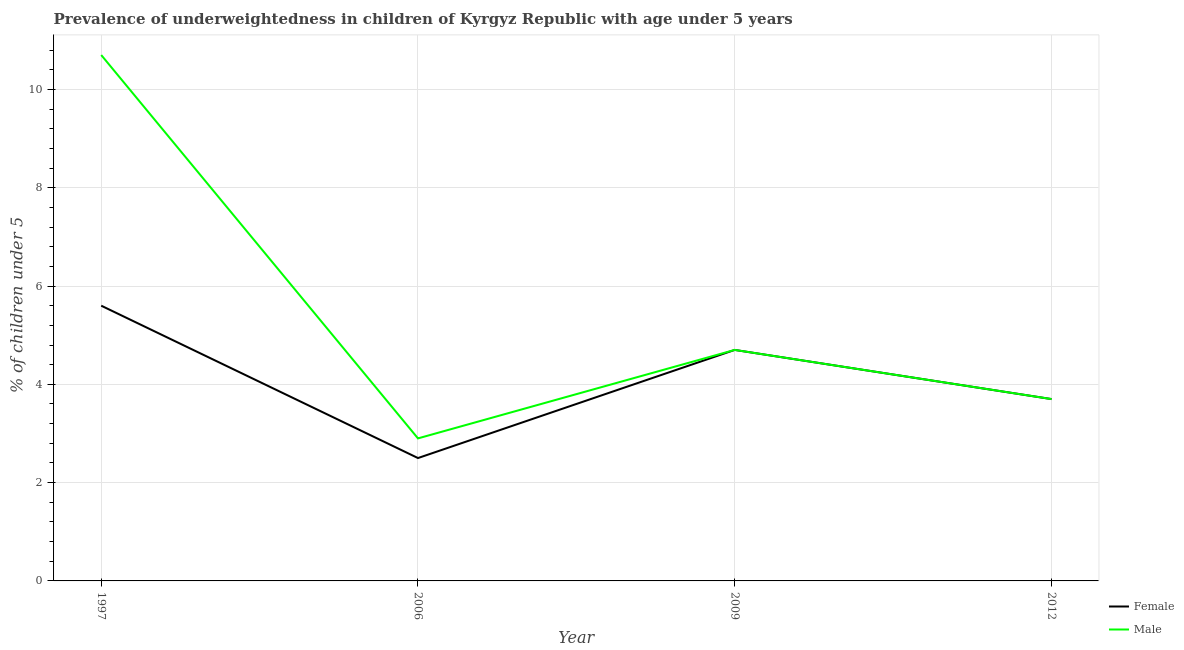How many different coloured lines are there?
Your response must be concise. 2. Across all years, what is the maximum percentage of underweighted female children?
Give a very brief answer. 5.6. In which year was the percentage of underweighted female children maximum?
Give a very brief answer. 1997. What is the total percentage of underweighted female children in the graph?
Provide a short and direct response. 16.5. What is the difference between the percentage of underweighted male children in 1997 and that in 2012?
Give a very brief answer. 7. What is the difference between the percentage of underweighted female children in 2009 and the percentage of underweighted male children in 1997?
Offer a very short reply. -6. What is the average percentage of underweighted female children per year?
Provide a succinct answer. 4.12. What is the ratio of the percentage of underweighted male children in 1997 to that in 2012?
Your response must be concise. 2.89. Is the difference between the percentage of underweighted female children in 2006 and 2012 greater than the difference between the percentage of underweighted male children in 2006 and 2012?
Make the answer very short. No. What is the difference between the highest and the second highest percentage of underweighted female children?
Your answer should be compact. 0.9. What is the difference between the highest and the lowest percentage of underweighted female children?
Keep it short and to the point. 3.1. In how many years, is the percentage of underweighted male children greater than the average percentage of underweighted male children taken over all years?
Your answer should be compact. 1. Is the sum of the percentage of underweighted male children in 1997 and 2009 greater than the maximum percentage of underweighted female children across all years?
Provide a short and direct response. Yes. Does the percentage of underweighted male children monotonically increase over the years?
Provide a short and direct response. No. Is the percentage of underweighted male children strictly greater than the percentage of underweighted female children over the years?
Ensure brevity in your answer.  No. Is the percentage of underweighted female children strictly less than the percentage of underweighted male children over the years?
Make the answer very short. No. How many lines are there?
Provide a succinct answer. 2. How many years are there in the graph?
Your answer should be compact. 4. What is the difference between two consecutive major ticks on the Y-axis?
Provide a succinct answer. 2. Are the values on the major ticks of Y-axis written in scientific E-notation?
Give a very brief answer. No. Does the graph contain any zero values?
Provide a short and direct response. No. How many legend labels are there?
Keep it short and to the point. 2. How are the legend labels stacked?
Your answer should be compact. Vertical. What is the title of the graph?
Keep it short and to the point. Prevalence of underweightedness in children of Kyrgyz Republic with age under 5 years. Does "Net National savings" appear as one of the legend labels in the graph?
Offer a very short reply. No. What is the label or title of the X-axis?
Your response must be concise. Year. What is the label or title of the Y-axis?
Give a very brief answer.  % of children under 5. What is the  % of children under 5 in Female in 1997?
Offer a very short reply. 5.6. What is the  % of children under 5 in Male in 1997?
Offer a terse response. 10.7. What is the  % of children under 5 in Male in 2006?
Offer a terse response. 2.9. What is the  % of children under 5 of Female in 2009?
Offer a very short reply. 4.7. What is the  % of children under 5 in Male in 2009?
Give a very brief answer. 4.7. What is the  % of children under 5 in Female in 2012?
Your answer should be very brief. 3.7. What is the  % of children under 5 of Male in 2012?
Your answer should be compact. 3.7. Across all years, what is the maximum  % of children under 5 of Female?
Give a very brief answer. 5.6. Across all years, what is the maximum  % of children under 5 of Male?
Give a very brief answer. 10.7. Across all years, what is the minimum  % of children under 5 of Male?
Ensure brevity in your answer.  2.9. What is the total  % of children under 5 in Male in the graph?
Keep it short and to the point. 22. What is the difference between the  % of children under 5 of Male in 1997 and that in 2006?
Your answer should be compact. 7.8. What is the difference between the  % of children under 5 in Female in 1997 and that in 2009?
Provide a short and direct response. 0.9. What is the difference between the  % of children under 5 in Female in 1997 and that in 2012?
Ensure brevity in your answer.  1.9. What is the difference between the  % of children under 5 in Female in 2006 and that in 2009?
Give a very brief answer. -2.2. What is the difference between the  % of children under 5 of Male in 2006 and that in 2012?
Offer a very short reply. -0.8. What is the difference between the  % of children under 5 in Female in 1997 and the  % of children under 5 in Male in 2006?
Keep it short and to the point. 2.7. What is the difference between the  % of children under 5 of Female in 1997 and the  % of children under 5 of Male in 2012?
Provide a short and direct response. 1.9. What is the average  % of children under 5 in Female per year?
Your answer should be very brief. 4.12. In the year 2006, what is the difference between the  % of children under 5 of Female and  % of children under 5 of Male?
Ensure brevity in your answer.  -0.4. In the year 2009, what is the difference between the  % of children under 5 of Female and  % of children under 5 of Male?
Make the answer very short. 0. What is the ratio of the  % of children under 5 of Female in 1997 to that in 2006?
Make the answer very short. 2.24. What is the ratio of the  % of children under 5 in Male in 1997 to that in 2006?
Give a very brief answer. 3.69. What is the ratio of the  % of children under 5 in Female in 1997 to that in 2009?
Offer a very short reply. 1.19. What is the ratio of the  % of children under 5 of Male in 1997 to that in 2009?
Your answer should be very brief. 2.28. What is the ratio of the  % of children under 5 in Female in 1997 to that in 2012?
Provide a succinct answer. 1.51. What is the ratio of the  % of children under 5 of Male in 1997 to that in 2012?
Offer a terse response. 2.89. What is the ratio of the  % of children under 5 in Female in 2006 to that in 2009?
Your answer should be compact. 0.53. What is the ratio of the  % of children under 5 of Male in 2006 to that in 2009?
Give a very brief answer. 0.62. What is the ratio of the  % of children under 5 of Female in 2006 to that in 2012?
Keep it short and to the point. 0.68. What is the ratio of the  % of children under 5 in Male in 2006 to that in 2012?
Keep it short and to the point. 0.78. What is the ratio of the  % of children under 5 of Female in 2009 to that in 2012?
Keep it short and to the point. 1.27. What is the ratio of the  % of children under 5 in Male in 2009 to that in 2012?
Provide a succinct answer. 1.27. What is the difference between the highest and the second highest  % of children under 5 of Male?
Make the answer very short. 6. What is the difference between the highest and the lowest  % of children under 5 of Female?
Provide a succinct answer. 3.1. 